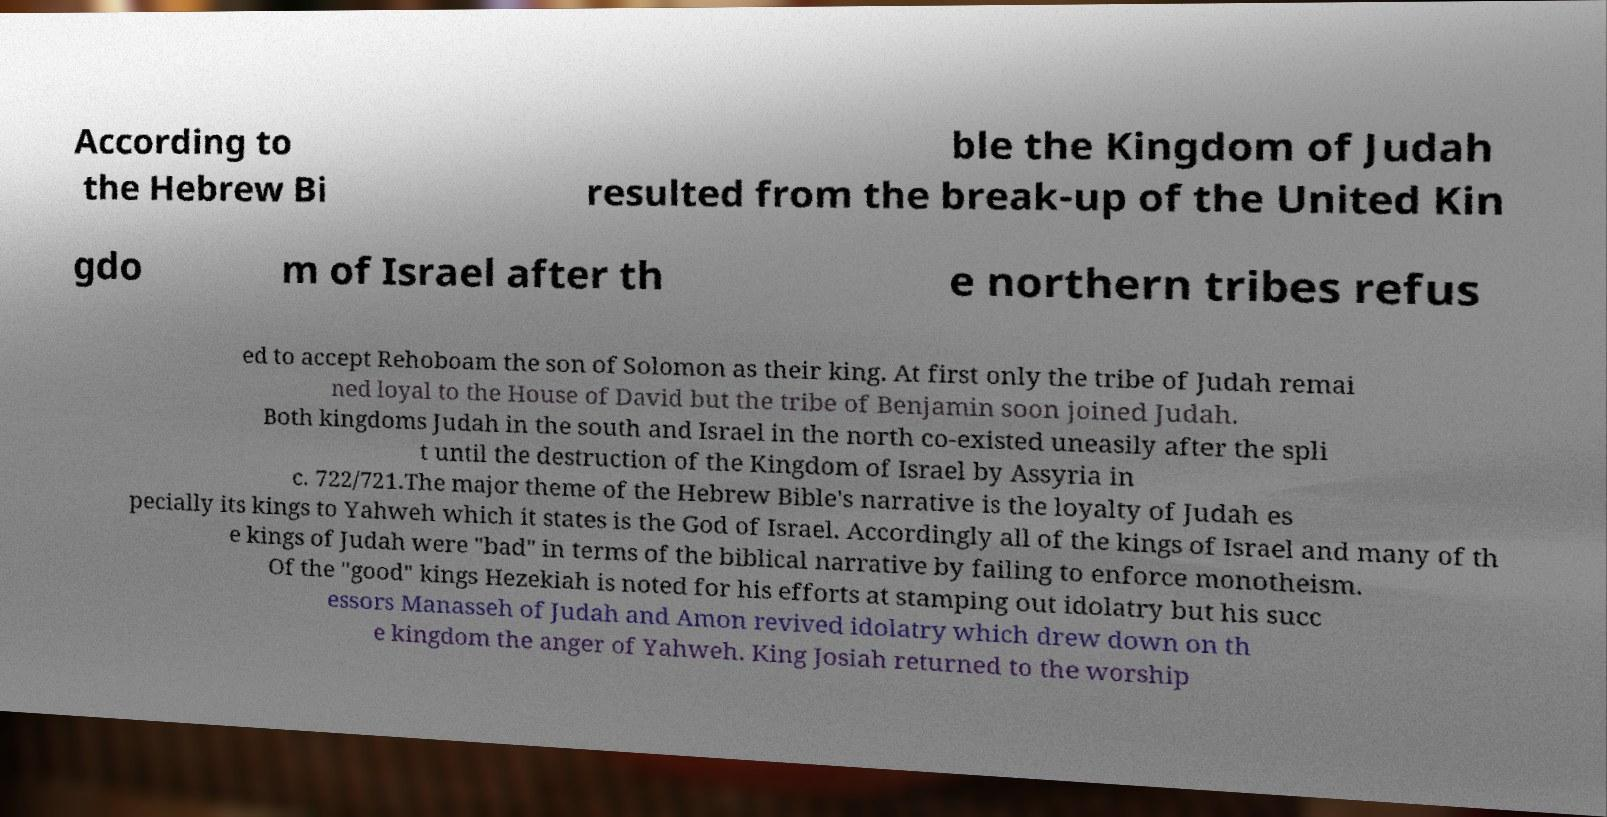Could you extract and type out the text from this image? According to the Hebrew Bi ble the Kingdom of Judah resulted from the break-up of the United Kin gdo m of Israel after th e northern tribes refus ed to accept Rehoboam the son of Solomon as their king. At first only the tribe of Judah remai ned loyal to the House of David but the tribe of Benjamin soon joined Judah. Both kingdoms Judah in the south and Israel in the north co-existed uneasily after the spli t until the destruction of the Kingdom of Israel by Assyria in c. 722/721.The major theme of the Hebrew Bible's narrative is the loyalty of Judah es pecially its kings to Yahweh which it states is the God of Israel. Accordingly all of the kings of Israel and many of th e kings of Judah were "bad" in terms of the biblical narrative by failing to enforce monotheism. Of the "good" kings Hezekiah is noted for his efforts at stamping out idolatry but his succ essors Manasseh of Judah and Amon revived idolatry which drew down on th e kingdom the anger of Yahweh. King Josiah returned to the worship 